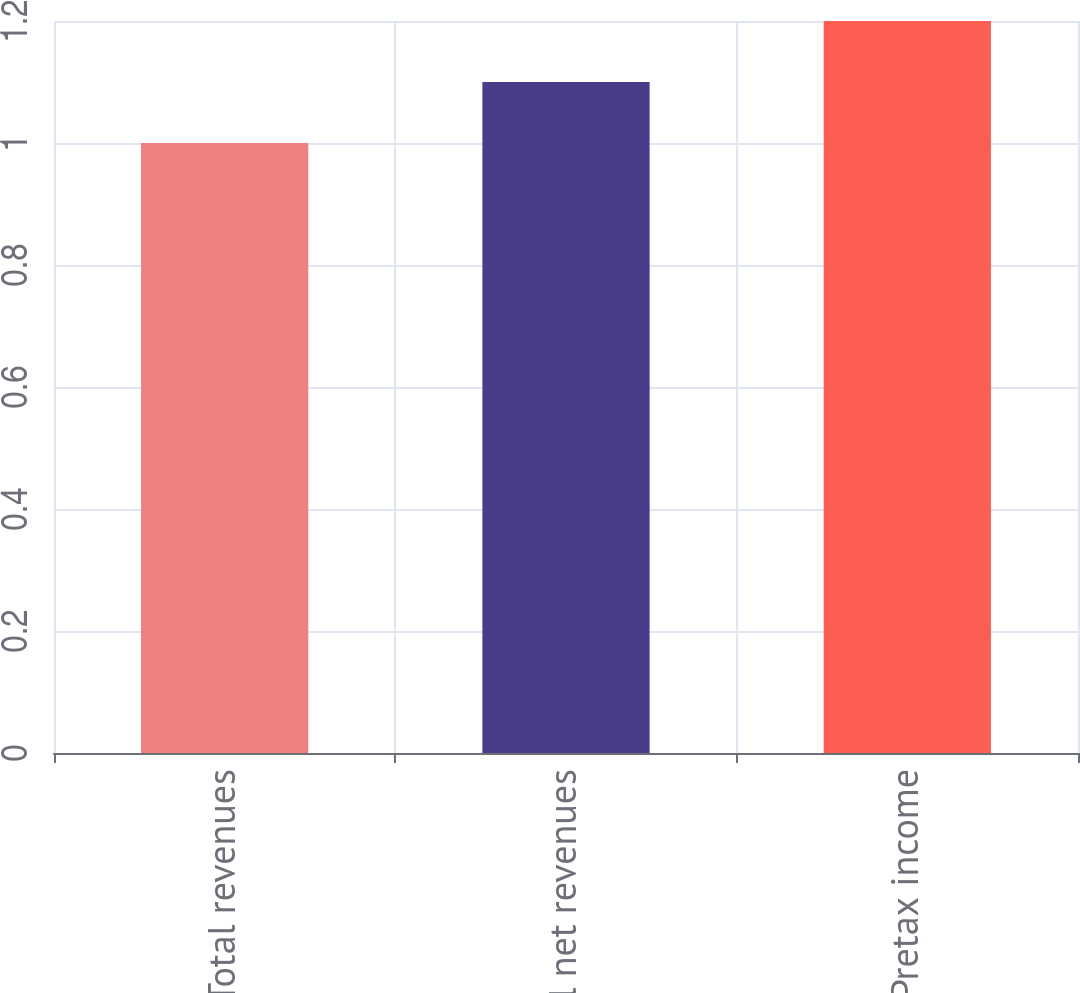Convert chart to OTSL. <chart><loc_0><loc_0><loc_500><loc_500><bar_chart><fcel>Total revenues<fcel>Total net revenues<fcel>Pretax income<nl><fcel>1<fcel>1.1<fcel>1.2<nl></chart> 